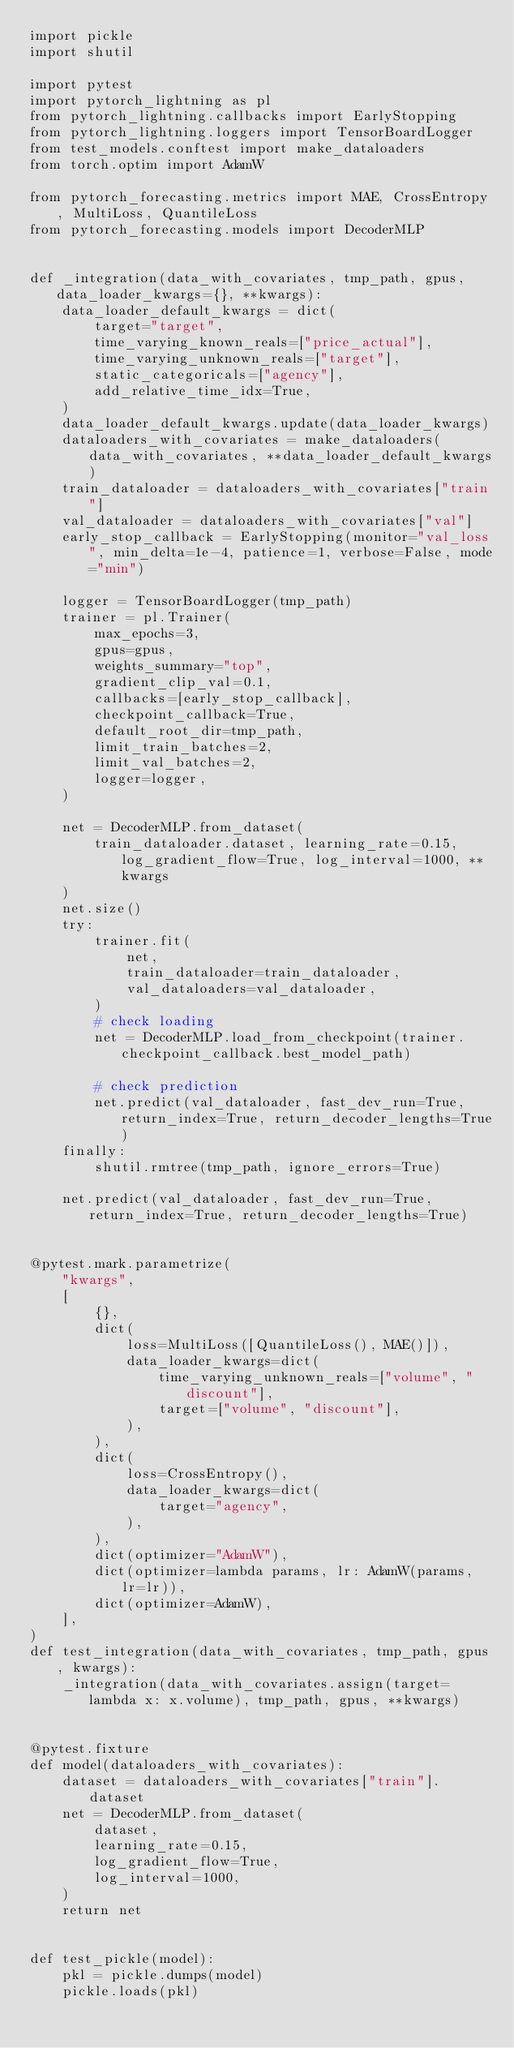Convert code to text. <code><loc_0><loc_0><loc_500><loc_500><_Python_>import pickle
import shutil

import pytest
import pytorch_lightning as pl
from pytorch_lightning.callbacks import EarlyStopping
from pytorch_lightning.loggers import TensorBoardLogger
from test_models.conftest import make_dataloaders
from torch.optim import AdamW

from pytorch_forecasting.metrics import MAE, CrossEntropy, MultiLoss, QuantileLoss
from pytorch_forecasting.models import DecoderMLP


def _integration(data_with_covariates, tmp_path, gpus, data_loader_kwargs={}, **kwargs):
    data_loader_default_kwargs = dict(
        target="target",
        time_varying_known_reals=["price_actual"],
        time_varying_unknown_reals=["target"],
        static_categoricals=["agency"],
        add_relative_time_idx=True,
    )
    data_loader_default_kwargs.update(data_loader_kwargs)
    dataloaders_with_covariates = make_dataloaders(data_with_covariates, **data_loader_default_kwargs)
    train_dataloader = dataloaders_with_covariates["train"]
    val_dataloader = dataloaders_with_covariates["val"]
    early_stop_callback = EarlyStopping(monitor="val_loss", min_delta=1e-4, patience=1, verbose=False, mode="min")

    logger = TensorBoardLogger(tmp_path)
    trainer = pl.Trainer(
        max_epochs=3,
        gpus=gpus,
        weights_summary="top",
        gradient_clip_val=0.1,
        callbacks=[early_stop_callback],
        checkpoint_callback=True,
        default_root_dir=tmp_path,
        limit_train_batches=2,
        limit_val_batches=2,
        logger=logger,
    )

    net = DecoderMLP.from_dataset(
        train_dataloader.dataset, learning_rate=0.15, log_gradient_flow=True, log_interval=1000, **kwargs
    )
    net.size()
    try:
        trainer.fit(
            net,
            train_dataloader=train_dataloader,
            val_dataloaders=val_dataloader,
        )
        # check loading
        net = DecoderMLP.load_from_checkpoint(trainer.checkpoint_callback.best_model_path)

        # check prediction
        net.predict(val_dataloader, fast_dev_run=True, return_index=True, return_decoder_lengths=True)
    finally:
        shutil.rmtree(tmp_path, ignore_errors=True)

    net.predict(val_dataloader, fast_dev_run=True, return_index=True, return_decoder_lengths=True)


@pytest.mark.parametrize(
    "kwargs",
    [
        {},
        dict(
            loss=MultiLoss([QuantileLoss(), MAE()]),
            data_loader_kwargs=dict(
                time_varying_unknown_reals=["volume", "discount"],
                target=["volume", "discount"],
            ),
        ),
        dict(
            loss=CrossEntropy(),
            data_loader_kwargs=dict(
                target="agency",
            ),
        ),
        dict(optimizer="AdamW"),
        dict(optimizer=lambda params, lr: AdamW(params, lr=lr)),
        dict(optimizer=AdamW),
    ],
)
def test_integration(data_with_covariates, tmp_path, gpus, kwargs):
    _integration(data_with_covariates.assign(target=lambda x: x.volume), tmp_path, gpus, **kwargs)


@pytest.fixture
def model(dataloaders_with_covariates):
    dataset = dataloaders_with_covariates["train"].dataset
    net = DecoderMLP.from_dataset(
        dataset,
        learning_rate=0.15,
        log_gradient_flow=True,
        log_interval=1000,
    )
    return net


def test_pickle(model):
    pkl = pickle.dumps(model)
    pickle.loads(pkl)
</code> 